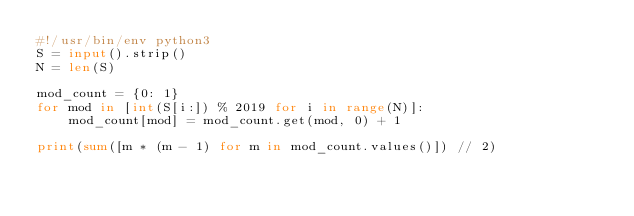Convert code to text. <code><loc_0><loc_0><loc_500><loc_500><_Python_>#!/usr/bin/env python3
S = input().strip()
N = len(S)

mod_count = {0: 1}
for mod in [int(S[i:]) % 2019 for i in range(N)]:
    mod_count[mod] = mod_count.get(mod, 0) + 1

print(sum([m * (m - 1) for m in mod_count.values()]) // 2)</code> 